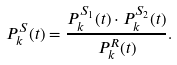<formula> <loc_0><loc_0><loc_500><loc_500>P ^ { S } _ { k } ( t ) = \frac { P ^ { S _ { 1 } } _ { k } ( t ) \cdot P ^ { S _ { 2 } } _ { k } ( t ) } { P ^ { R } _ { k } ( t ) } .</formula> 